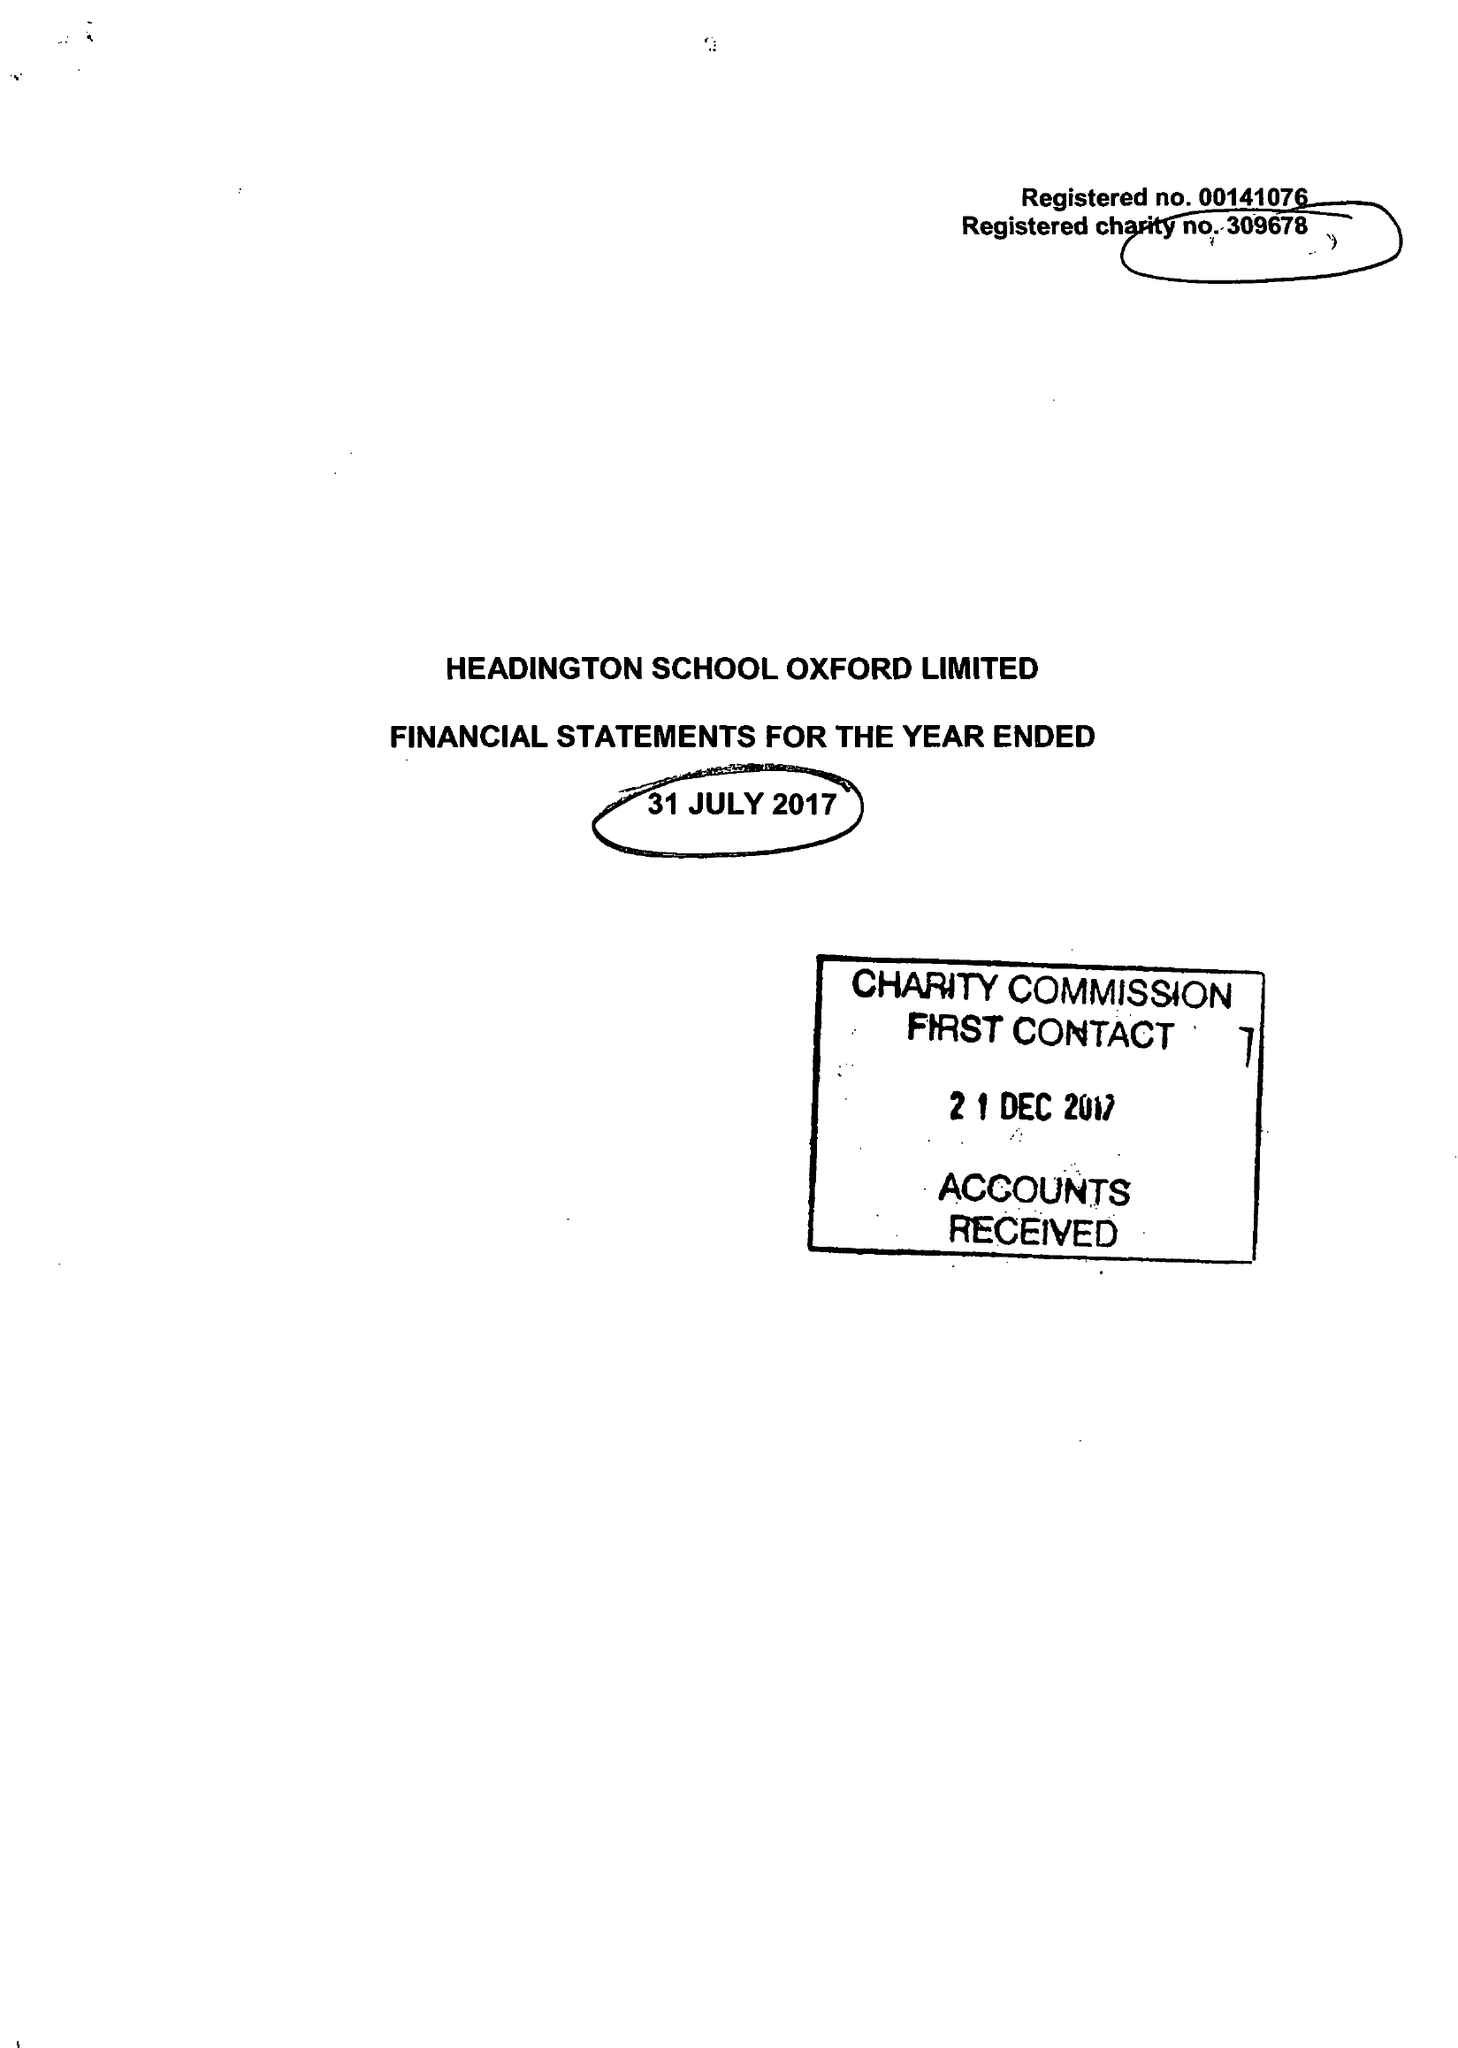What is the value for the charity_number?
Answer the question using a single word or phrase. 309678 